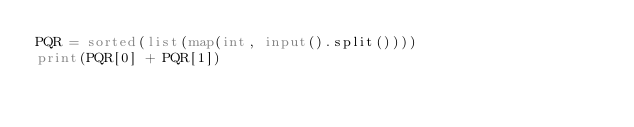<code> <loc_0><loc_0><loc_500><loc_500><_Python_>PQR = sorted(list(map(int, input().split())))
print(PQR[0] + PQR[1])

</code> 